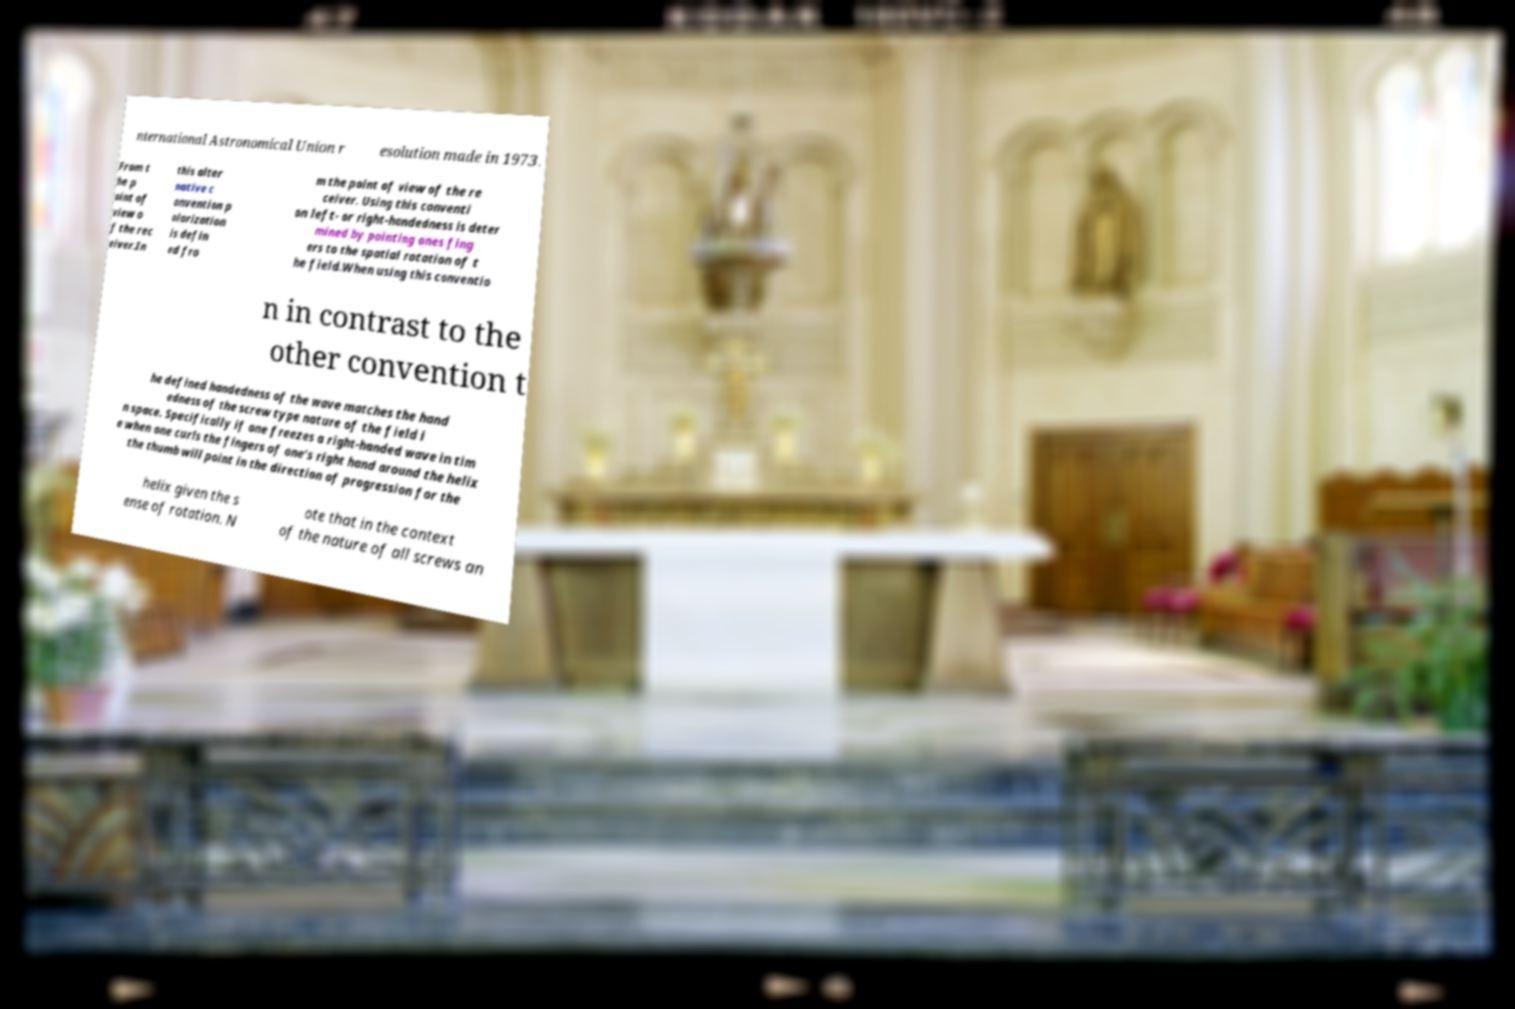Could you assist in decoding the text presented in this image and type it out clearly? nternational Astronomical Union r esolution made in 1973. From t he p oint of view o f the rec eiver.In this alter native c onvention p olarization is defin ed fro m the point of view of the re ceiver. Using this conventi on left- or right-handedness is deter mined by pointing ones fing ers to the spatial rotation of t he field.When using this conventio n in contrast to the other convention t he defined handedness of the wave matches the hand edness of the screw type nature of the field i n space. Specifically if one freezes a right-handed wave in tim e when one curls the fingers of one's right hand around the helix the thumb will point in the direction of progression for the helix given the s ense of rotation. N ote that in the context of the nature of all screws an 